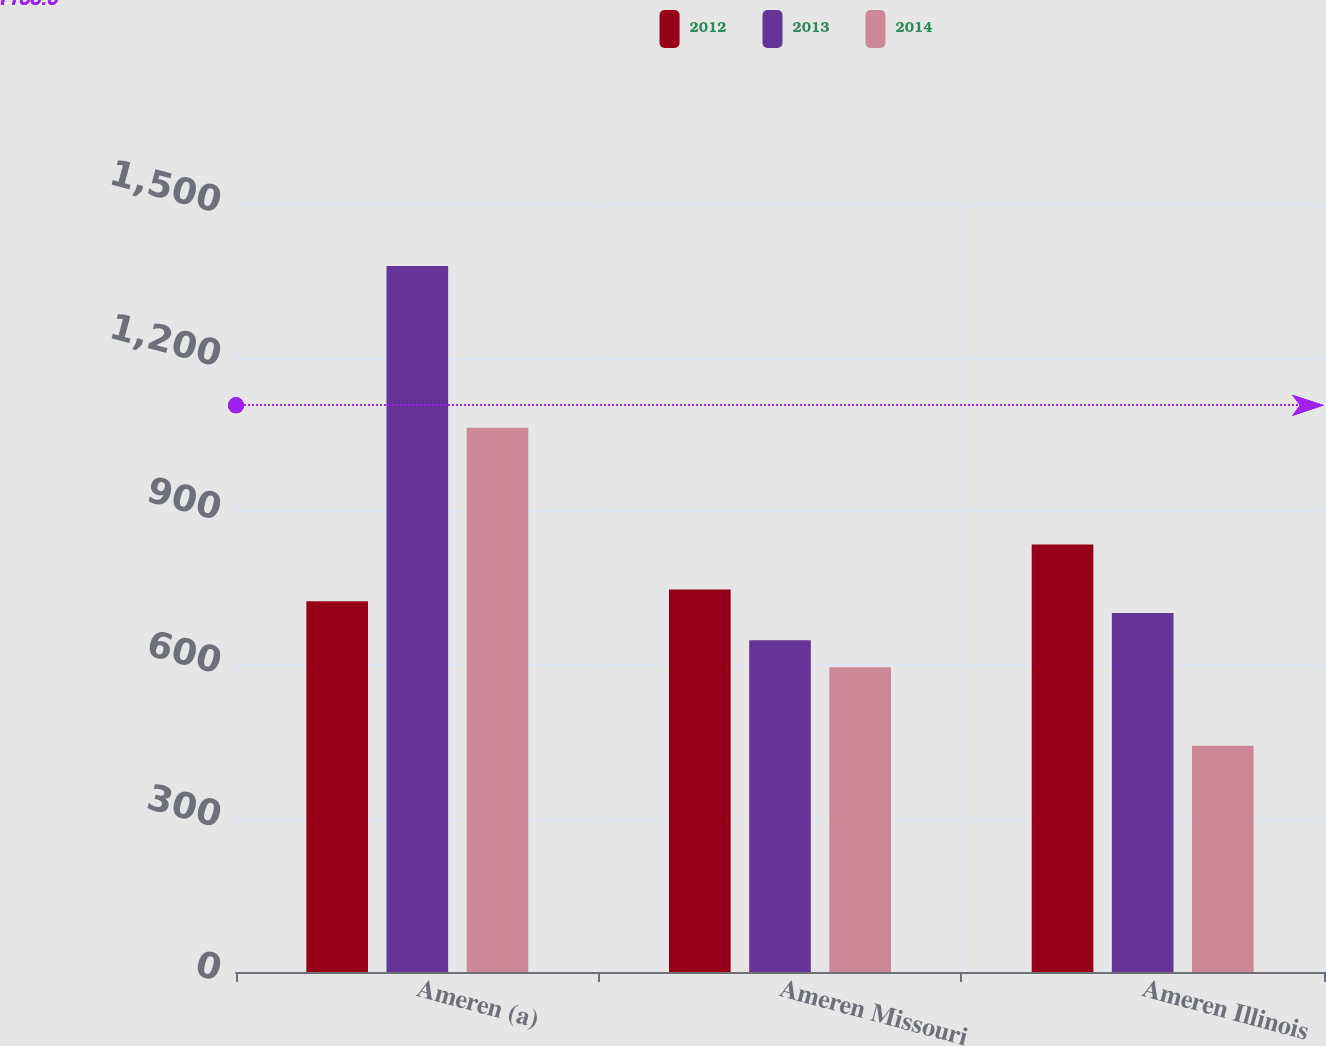Convert chart to OTSL. <chart><loc_0><loc_0><loc_500><loc_500><stacked_bar_chart><ecel><fcel>Ameren (a)<fcel>Ameren Missouri<fcel>Ameren Illinois<nl><fcel>2012<fcel>724<fcel>747<fcel>835<nl><fcel>2013<fcel>1379<fcel>648<fcel>701<nl><fcel>2014<fcel>1063<fcel>595<fcel>442<nl></chart> 